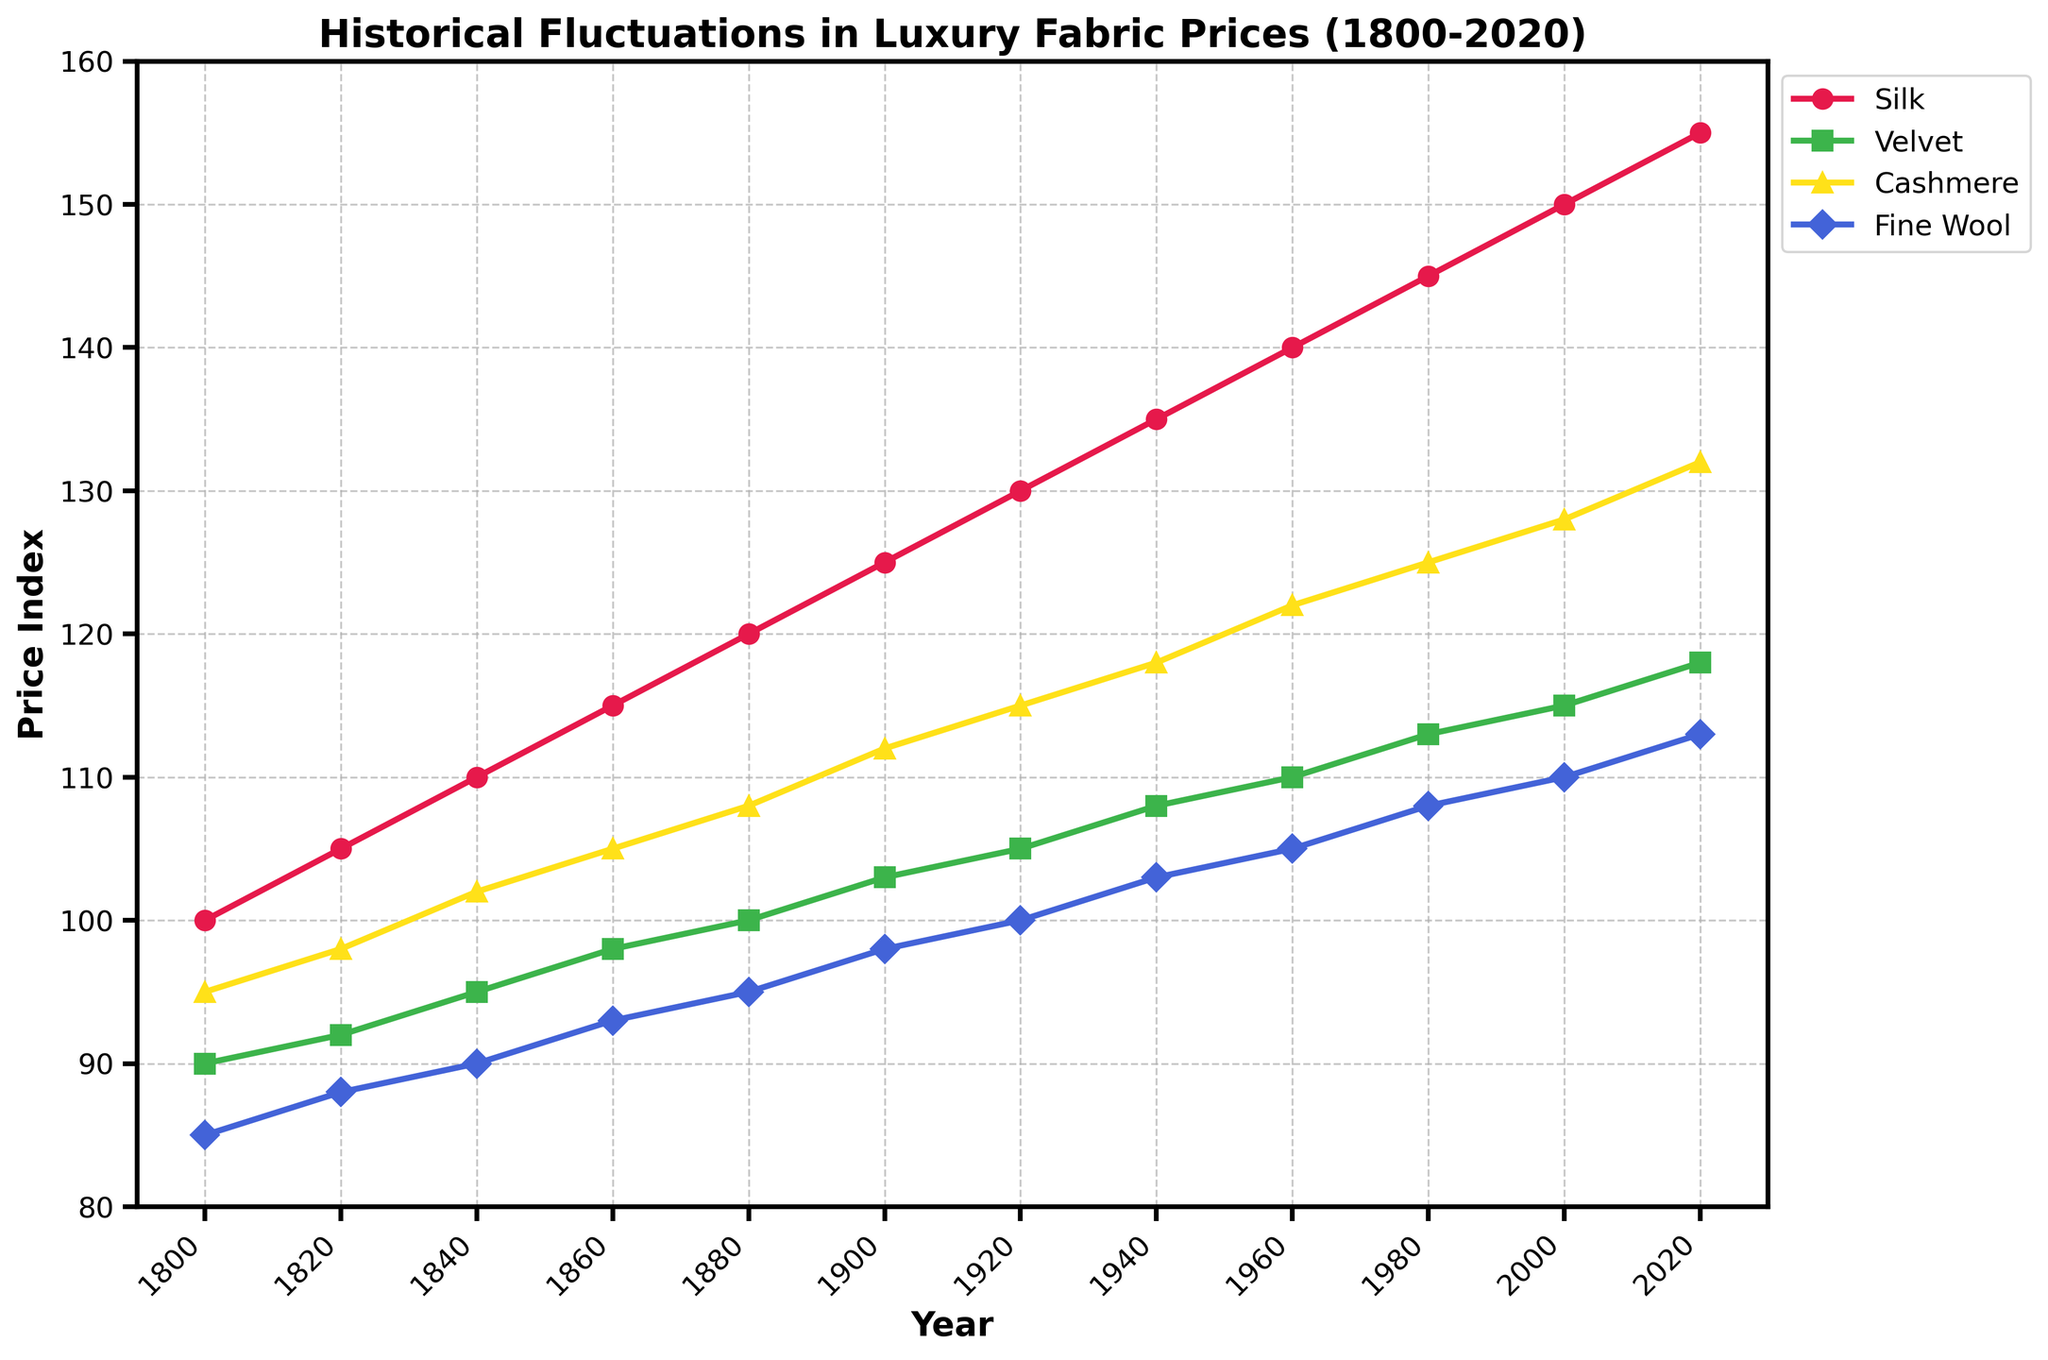What year did the price of Silk first reach 150? The graph shows the price index for Silk by year. Trace the Silk line to find the first year where the price hits 150.
Answer: 2000 Which fabric had the highest price index in 1900? Identify the year 1900 on the x-axis and then check the price index of Silk, Velvet, Cashmere, and Fine Wool for that year. Compare the values to determine which is the highest.
Answer: Silk From 1940 to 1980, which fabric had the greatest price increase? Note the price index of each fabric in 1940 and 1980. Subtract the 1940 value from the 1980 value for each fabric to determine the increase. Compare these differences to find the greatest increase.
Answer: Silk Which fabric demonstrated the most consistent price increase over the entire period? Follow each fabric's line from 1800 to 2020 and observe the smoothness and steadiness of the incline. The fabric with the smoothest, most even increase indicates the most consistent price rise.
Answer: Silk In what range did the price of Fine Wool fluctuate from 1800 to 2020? Observe the highest and lowest points of the Fine Wool line from 1800 to 2020. Note these values to determine the range.
Answer: 85 to 113 By how much did the price of Cashmere increase from 1800 to 2020? Subtract the price of Cashmere in 1800 from its price in 2020.
Answer: 37 Was there a period where the price of Velvet was higher than the price of Cashmere? Compare the Velvet and Cashmere lines over the entire timeline to see if the Velvet line goes above the Cashmere line at any point.
Answer: No During which period did Fine Wool have the smallest price increase? Calculate the price difference of Fine Wool in each 20-year period (e.g., 1800 to 1820, 1820 to 1840, etc.). Determine which period has the smallest increase by comparing the differences.
Answer: 1800 to 1820 How does the price of Velvet in 1920 compare to the price of Fine Wool in 2000? Find the values for Velvet in 1920 and Fine Wool in 2000 on the y-axis. Compare these two values directly.
Answer: Velvet in 1920 is higher What is the average price of Velvet from 1800 to 2020? Sum the price values of Velvet for each year provided (1800, 1820, etc.) and divide by the number of data points (12).
Answer: 103.5 